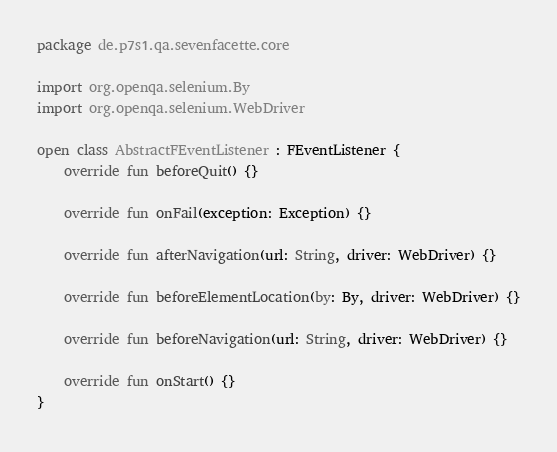Convert code to text. <code><loc_0><loc_0><loc_500><loc_500><_Kotlin_>package de.p7s1.qa.sevenfacette.core

import org.openqa.selenium.By
import org.openqa.selenium.WebDriver

open class AbstractFEventListener : FEventListener {
    override fun beforeQuit() {}

    override fun onFail(exception: Exception) {}

    override fun afterNavigation(url: String, driver: WebDriver) {}

    override fun beforeElementLocation(by: By, driver: WebDriver) {}

    override fun beforeNavigation(url: String, driver: WebDriver) {}

    override fun onStart() {}
}
</code> 